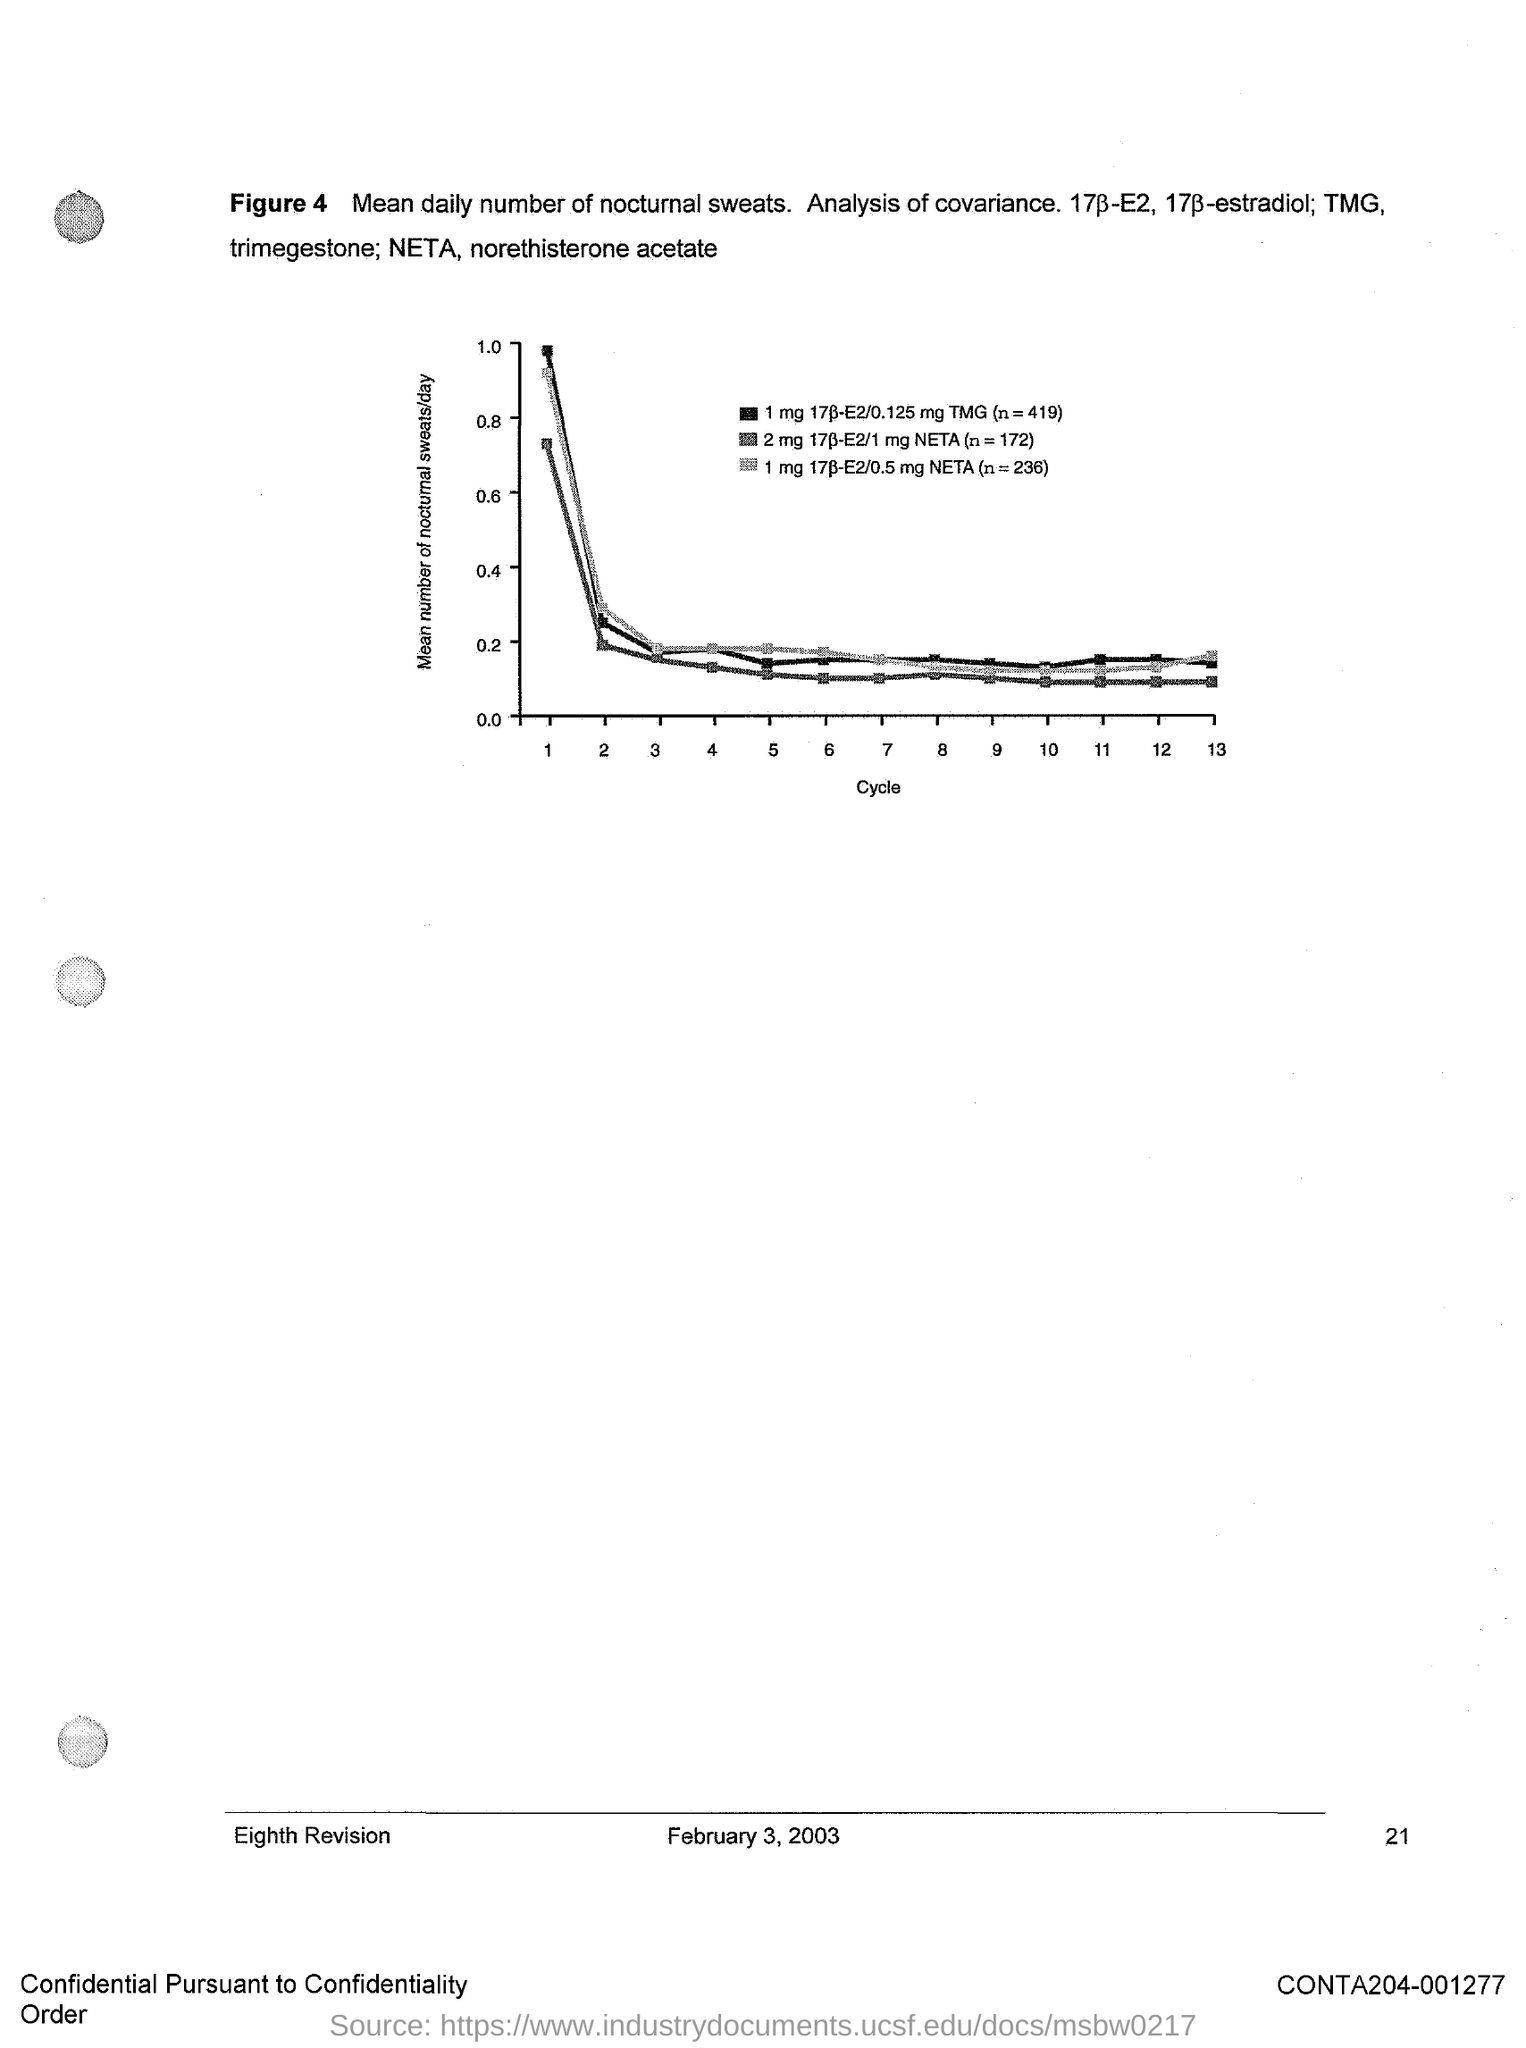What is the date on the document?
Offer a terse response. February 3, 2003. What is the Page Number?
Ensure brevity in your answer.  21. 